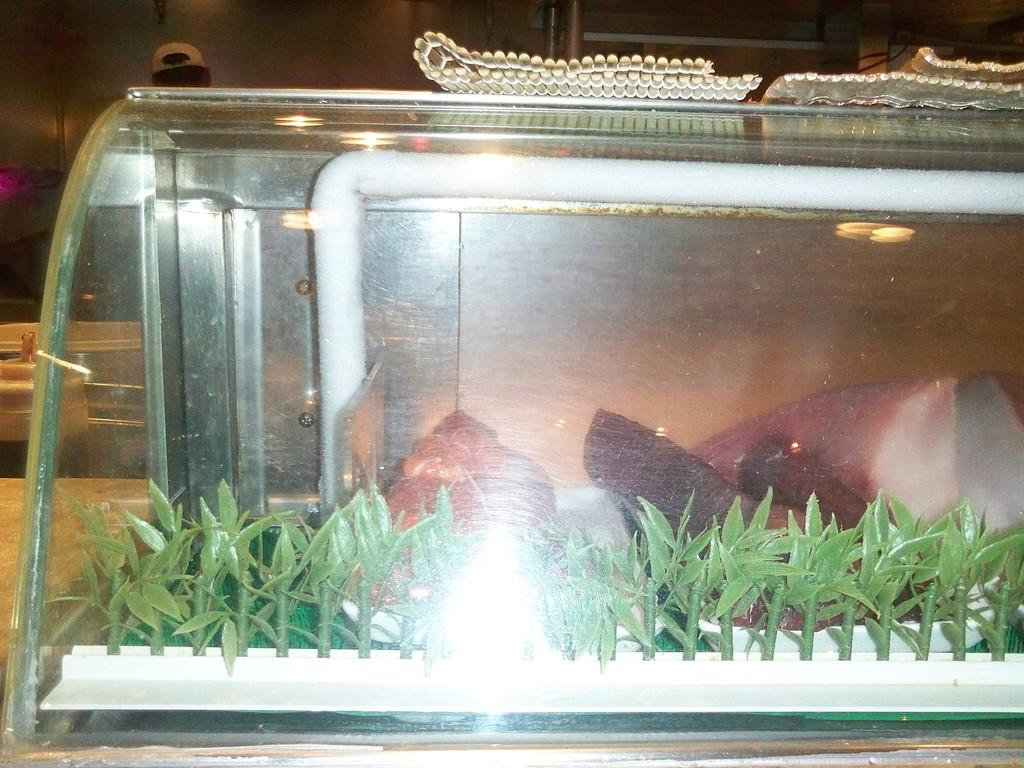What types of items can be seen in the image? There are food items and depictions of plants in the image. How are the food items and depictions of plants arranged in the image? They are placed in a glass object. Can you describe the person in the background of the image? There is a person wearing a cap in the background of the image. What type of furniture is present in the image? There is no furniture present in the image. 